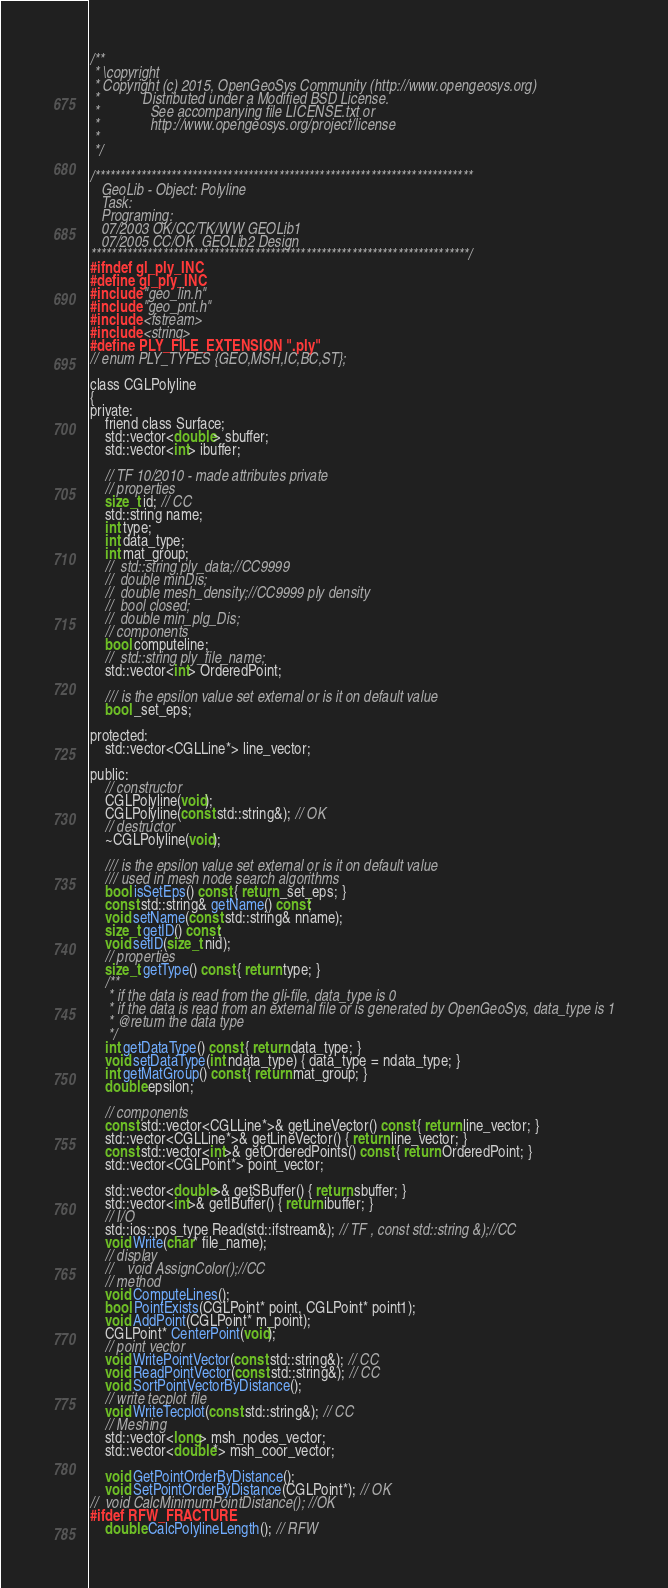Convert code to text. <code><loc_0><loc_0><loc_500><loc_500><_C_>/**
 * \copyright
 * Copyright (c) 2015, OpenGeoSys Community (http://www.opengeosys.org)
 *            Distributed under a Modified BSD License.
 *              See accompanying file LICENSE.txt or
 *              http://www.opengeosys.org/project/license
 *
 */

/**************************************************************************
   GeoLib - Object: Polyline
   Task:
   Programing:
   07/2003 OK/CC/TK/WW GEOLib1
   07/2005 CC/OK  GEOLib2 Design
**************************************************************************/
#ifndef gl_ply_INC
#define gl_ply_INC
#include "geo_lin.h"
#include "geo_pnt.h"
#include <fstream>
#include <string>
#define PLY_FILE_EXTENSION ".ply"
// enum PLY_TYPES {GEO,MSH,IC,BC,ST};

class CGLPolyline
{
private:
	friend class Surface;
	std::vector<double> sbuffer;
	std::vector<int> ibuffer;

	// TF 10/2010 - made attributes private
	// properties
	size_t id; // CC
	std::string name;
	int type;
	int data_type;
	int mat_group;
	//	std::string ply_data;//CC9999
	//	double minDis;
	//	double mesh_density;//CC9999 ply density
	//	bool closed;
	//	double min_plg_Dis;
	// components
	bool computeline;
	//	std::string ply_file_name;
	std::vector<int> OrderedPoint;

	/// is the epsilon value set external or is it on default value
	bool _set_eps;

protected:
	std::vector<CGLLine*> line_vector;

public:
	// constructor
	CGLPolyline(void);
	CGLPolyline(const std::string&); // OK
	// destructor
	~CGLPolyline(void);

	/// is the epsilon value set external or is it on default value
	/// used in mesh node search algorithms
	bool isSetEps() const { return _set_eps; }
	const std::string& getName() const;
	void setName(const std::string& nname);
	size_t getID() const;
	void setID(size_t nid);
	// properties
	size_t getType() const { return type; }
	/**
	 * if the data is read from the gli-file, data_type is 0
	 * if the data is read from an external file or is generated by OpenGeoSys, data_type is 1
	 * @return the data type
	 */
	int getDataType() const { return data_type; }
	void setDataType(int ndata_type) { data_type = ndata_type; }
	int getMatGroup() const { return mat_group; }
	double epsilon;

	// components
	const std::vector<CGLLine*>& getLineVector() const { return line_vector; }
	std::vector<CGLLine*>& getLineVector() { return line_vector; }
	const std::vector<int>& getOrderedPoints() const { return OrderedPoint; }
	std::vector<CGLPoint*> point_vector;

	std::vector<double>& getSBuffer() { return sbuffer; }
	std::vector<int>& getIBuffer() { return ibuffer; }
	// I/O
	std::ios::pos_type Read(std::ifstream&); // TF , const std::string &);//CC
	void Write(char* file_name);
	// display
	//    void AssignColor();//CC
	// method
	void ComputeLines();
	bool PointExists(CGLPoint* point, CGLPoint* point1);
	void AddPoint(CGLPoint* m_point);
	CGLPoint* CenterPoint(void);
	// point vector
	void WritePointVector(const std::string&); // CC
	void ReadPointVector(const std::string&); // CC
	void SortPointVectorByDistance();
	// write tecplot file
	void WriteTecplot(const std::string&); // CC
	// Meshing
	std::vector<long> msh_nodes_vector;
	std::vector<double*> msh_coor_vector;

	void GetPointOrderByDistance();
	void SetPointOrderByDistance(CGLPoint*); // OK
//	void CalcMinimumPointDistance(); //OK
#ifdef RFW_FRACTURE
	double CalcPolylineLength(); // RFW</code> 